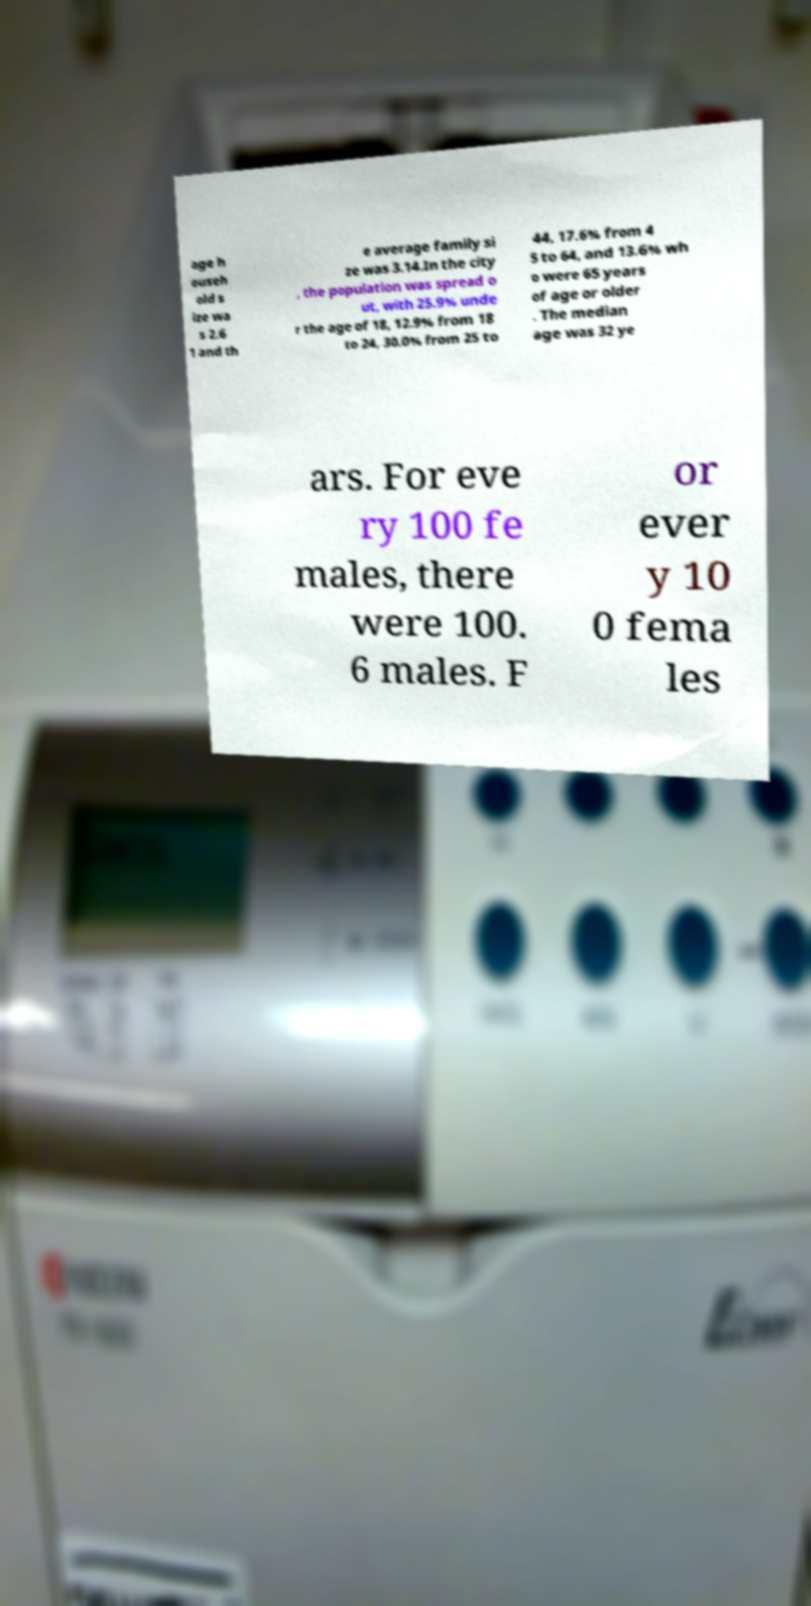Please identify and transcribe the text found in this image. age h ouseh old s ize wa s 2.6 1 and th e average family si ze was 3.14.In the city , the population was spread o ut, with 25.9% unde r the age of 18, 12.9% from 18 to 24, 30.0% from 25 to 44, 17.6% from 4 5 to 64, and 13.6% wh o were 65 years of age or older . The median age was 32 ye ars. For eve ry 100 fe males, there were 100. 6 males. F or ever y 10 0 fema les 